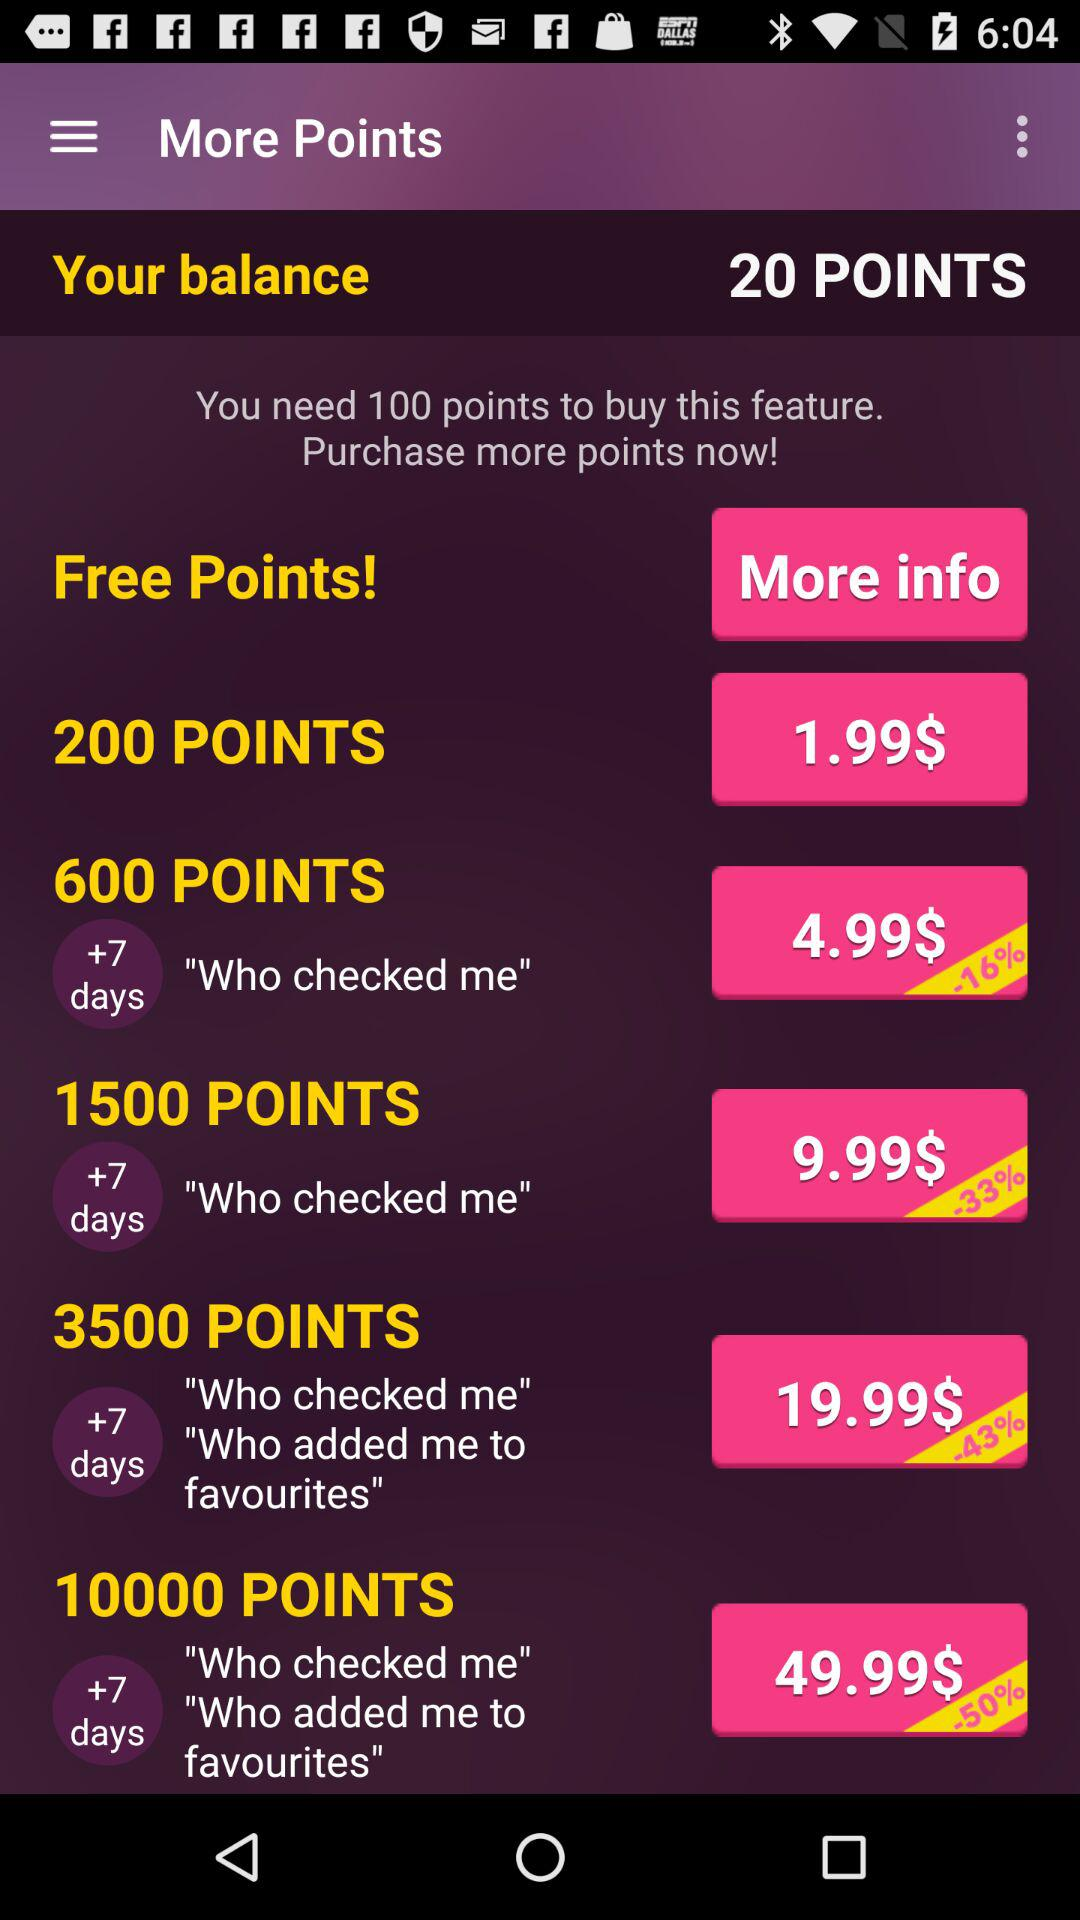How much do I need to pay to get 10000 points?
Answer the question using a single word or phrase. 49.99$ 